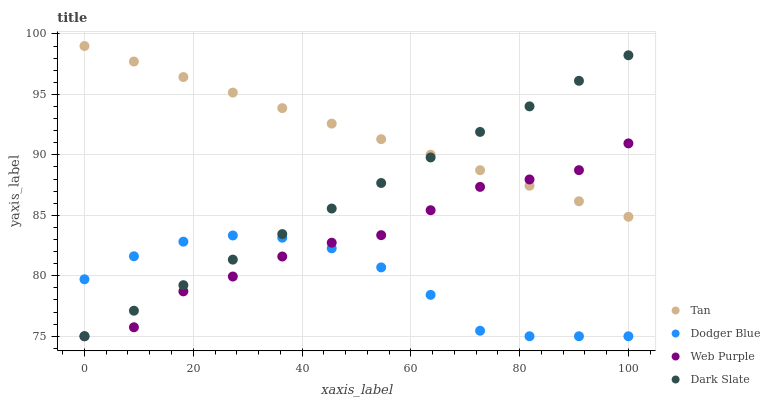Does Dodger Blue have the minimum area under the curve?
Answer yes or no. Yes. Does Tan have the maximum area under the curve?
Answer yes or no. Yes. Does Tan have the minimum area under the curve?
Answer yes or no. No. Does Dodger Blue have the maximum area under the curve?
Answer yes or no. No. Is Dark Slate the smoothest?
Answer yes or no. Yes. Is Web Purple the roughest?
Answer yes or no. Yes. Is Tan the smoothest?
Answer yes or no. No. Is Tan the roughest?
Answer yes or no. No. Does Dark Slate have the lowest value?
Answer yes or no. Yes. Does Tan have the lowest value?
Answer yes or no. No. Does Tan have the highest value?
Answer yes or no. Yes. Does Dodger Blue have the highest value?
Answer yes or no. No. Is Dodger Blue less than Tan?
Answer yes or no. Yes. Is Tan greater than Dodger Blue?
Answer yes or no. Yes. Does Dodger Blue intersect Web Purple?
Answer yes or no. Yes. Is Dodger Blue less than Web Purple?
Answer yes or no. No. Is Dodger Blue greater than Web Purple?
Answer yes or no. No. Does Dodger Blue intersect Tan?
Answer yes or no. No. 